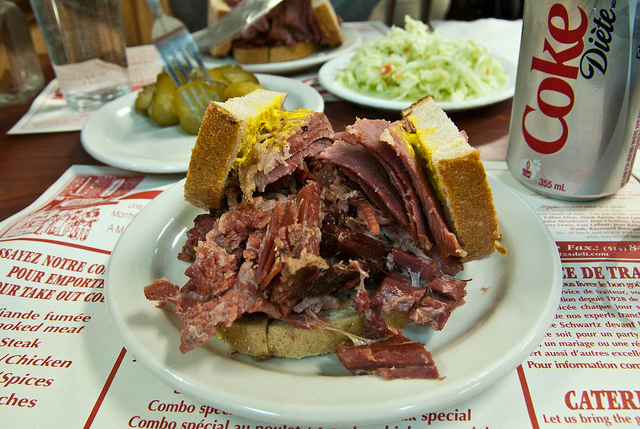Identify the text contained in this image. SAYEZ NOTRE CO POUR EMPORTE TAKE OUT CO Combo SP Coke Diete information Pour CO exce d'autres aussi marriage pour bon chaque experts TRA DE Fax the bring US Let CATER special special Combo ches Spices Chicken Steak ment fumee ml 355 